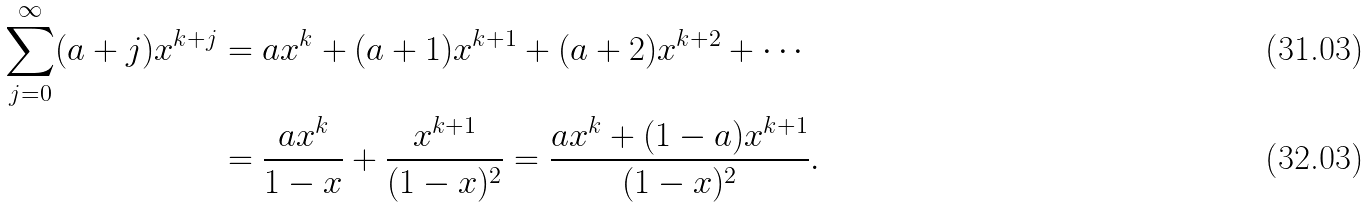<formula> <loc_0><loc_0><loc_500><loc_500>\sum _ { j = 0 } ^ { \infty } ( a + j ) x ^ { k + j } & = a x ^ { k } + ( a + 1 ) x ^ { k + 1 } + ( a + 2 ) x ^ { k + 2 } + \cdots \\ & = \frac { a x ^ { k } } { 1 - x } + \frac { x ^ { k + 1 } } { ( 1 - x ) ^ { 2 } } = \frac { a x ^ { k } + ( 1 - a ) x ^ { k + 1 } } { ( 1 - x ) ^ { 2 } } .</formula> 